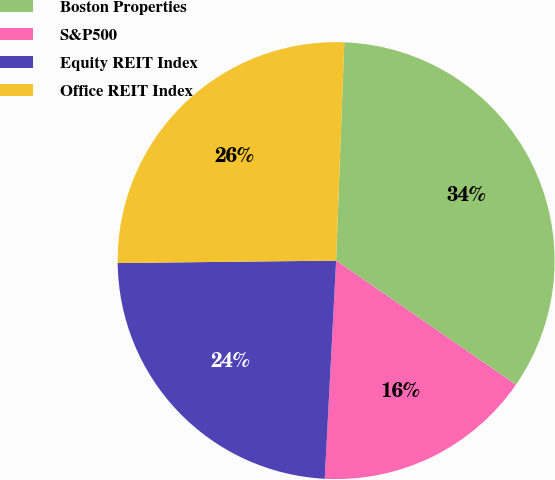<chart> <loc_0><loc_0><loc_500><loc_500><pie_chart><fcel>Boston Properties<fcel>S&P500<fcel>Equity REIT Index<fcel>Office REIT Index<nl><fcel>34.02%<fcel>16.21%<fcel>23.99%<fcel>25.77%<nl></chart> 